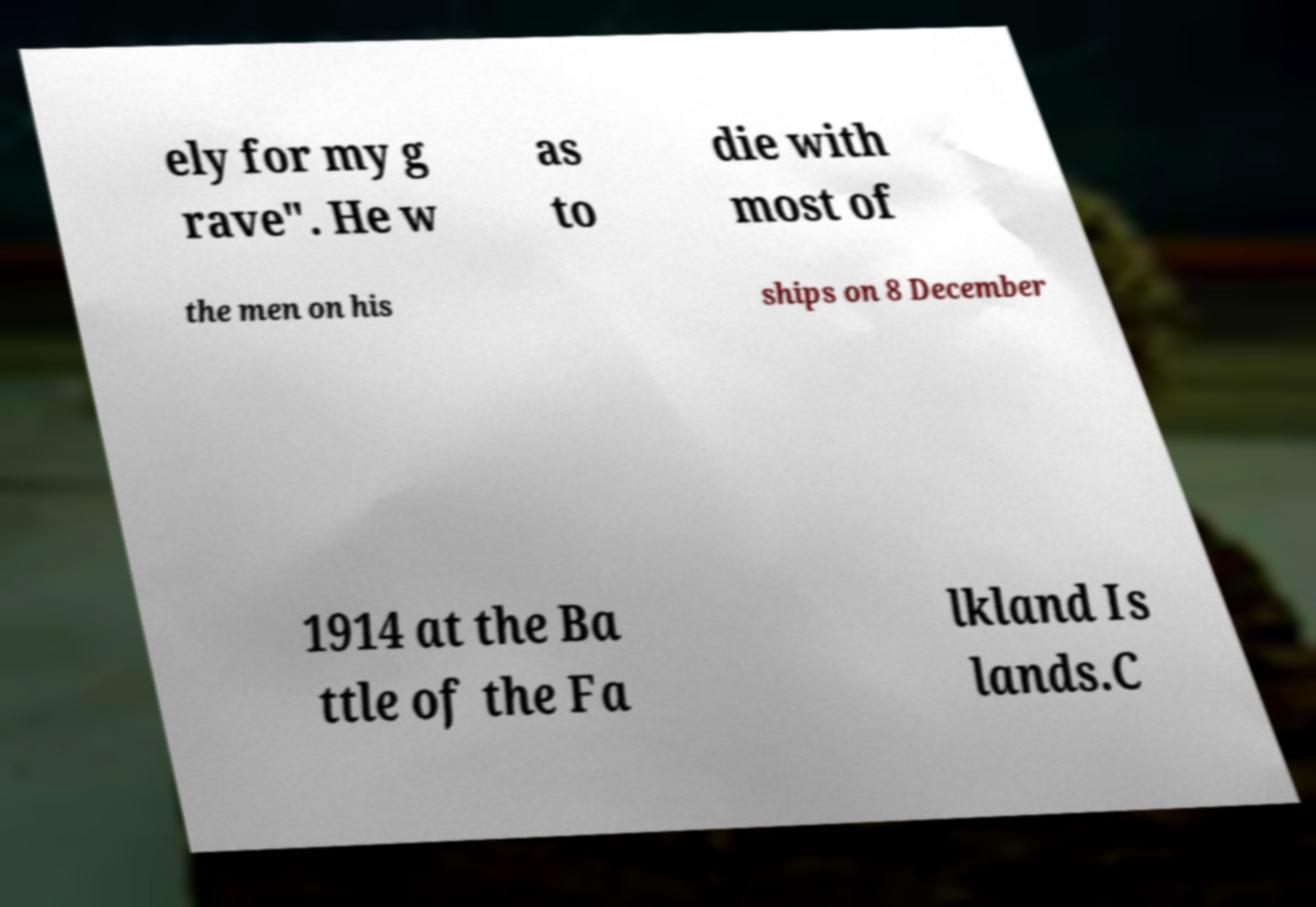Can you accurately transcribe the text from the provided image for me? ely for my g rave". He w as to die with most of the men on his ships on 8 December 1914 at the Ba ttle of the Fa lkland Is lands.C 